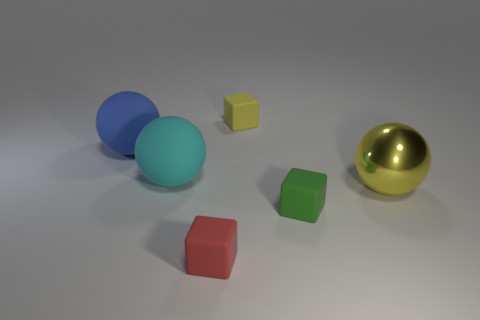What is the shape of the green object that is the same size as the yellow block?
Your response must be concise. Cube. What is the shape of the big blue thing?
Keep it short and to the point. Sphere. Is the material of the cube in front of the tiny green thing the same as the yellow sphere?
Your answer should be compact. No. There is a blue object left of the yellow object behind the blue object; how big is it?
Offer a terse response. Large. What color is the ball that is both to the left of the small red matte thing and right of the blue rubber object?
Ensure brevity in your answer.  Cyan. There is a blue ball that is the same size as the yellow metal ball; what is it made of?
Give a very brief answer. Rubber. How many other objects are the same material as the big cyan thing?
Keep it short and to the point. 4. There is a rubber cube that is behind the tiny green rubber thing; is its color the same as the large thing to the right of the small yellow block?
Provide a succinct answer. Yes. What is the shape of the small rubber thing to the right of the yellow thing that is to the left of the large yellow shiny sphere?
Offer a terse response. Cube. What number of other things are there of the same color as the big metallic sphere?
Make the answer very short. 1. 